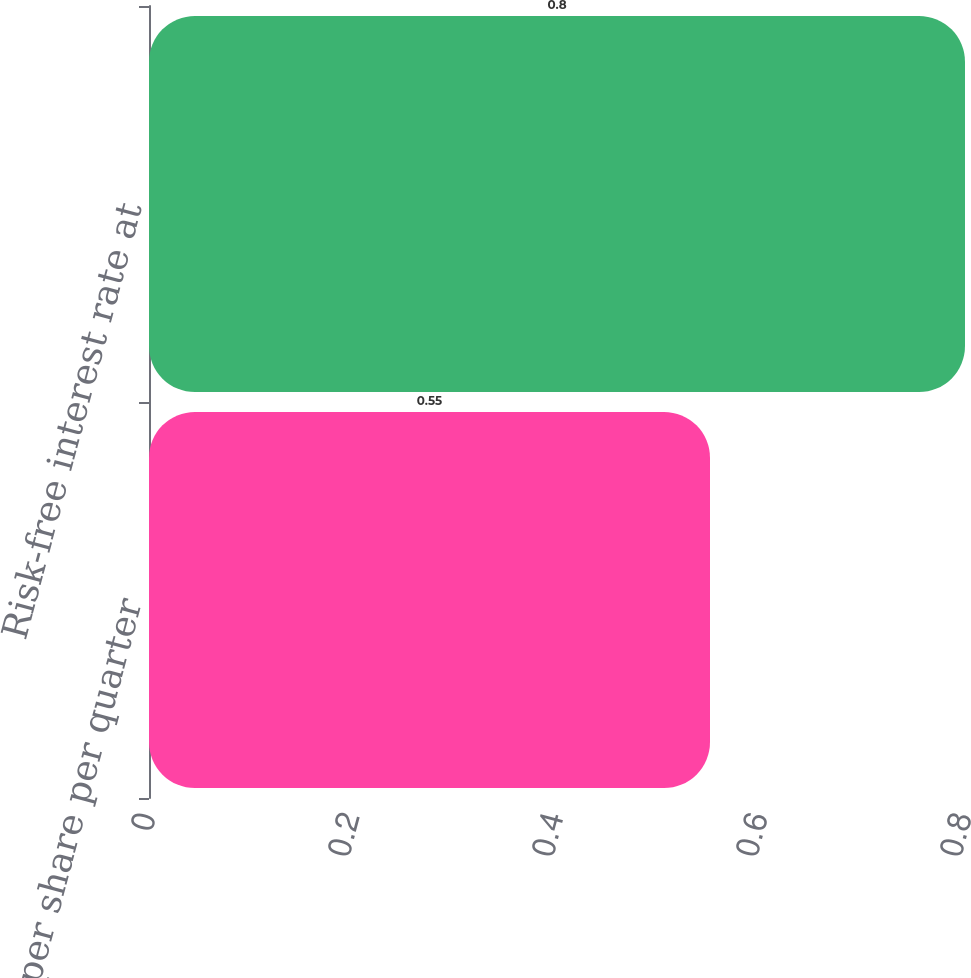Convert chart. <chart><loc_0><loc_0><loc_500><loc_500><bar_chart><fcel>Dividend per share per quarter<fcel>Risk-free interest rate at<nl><fcel>0.55<fcel>0.8<nl></chart> 